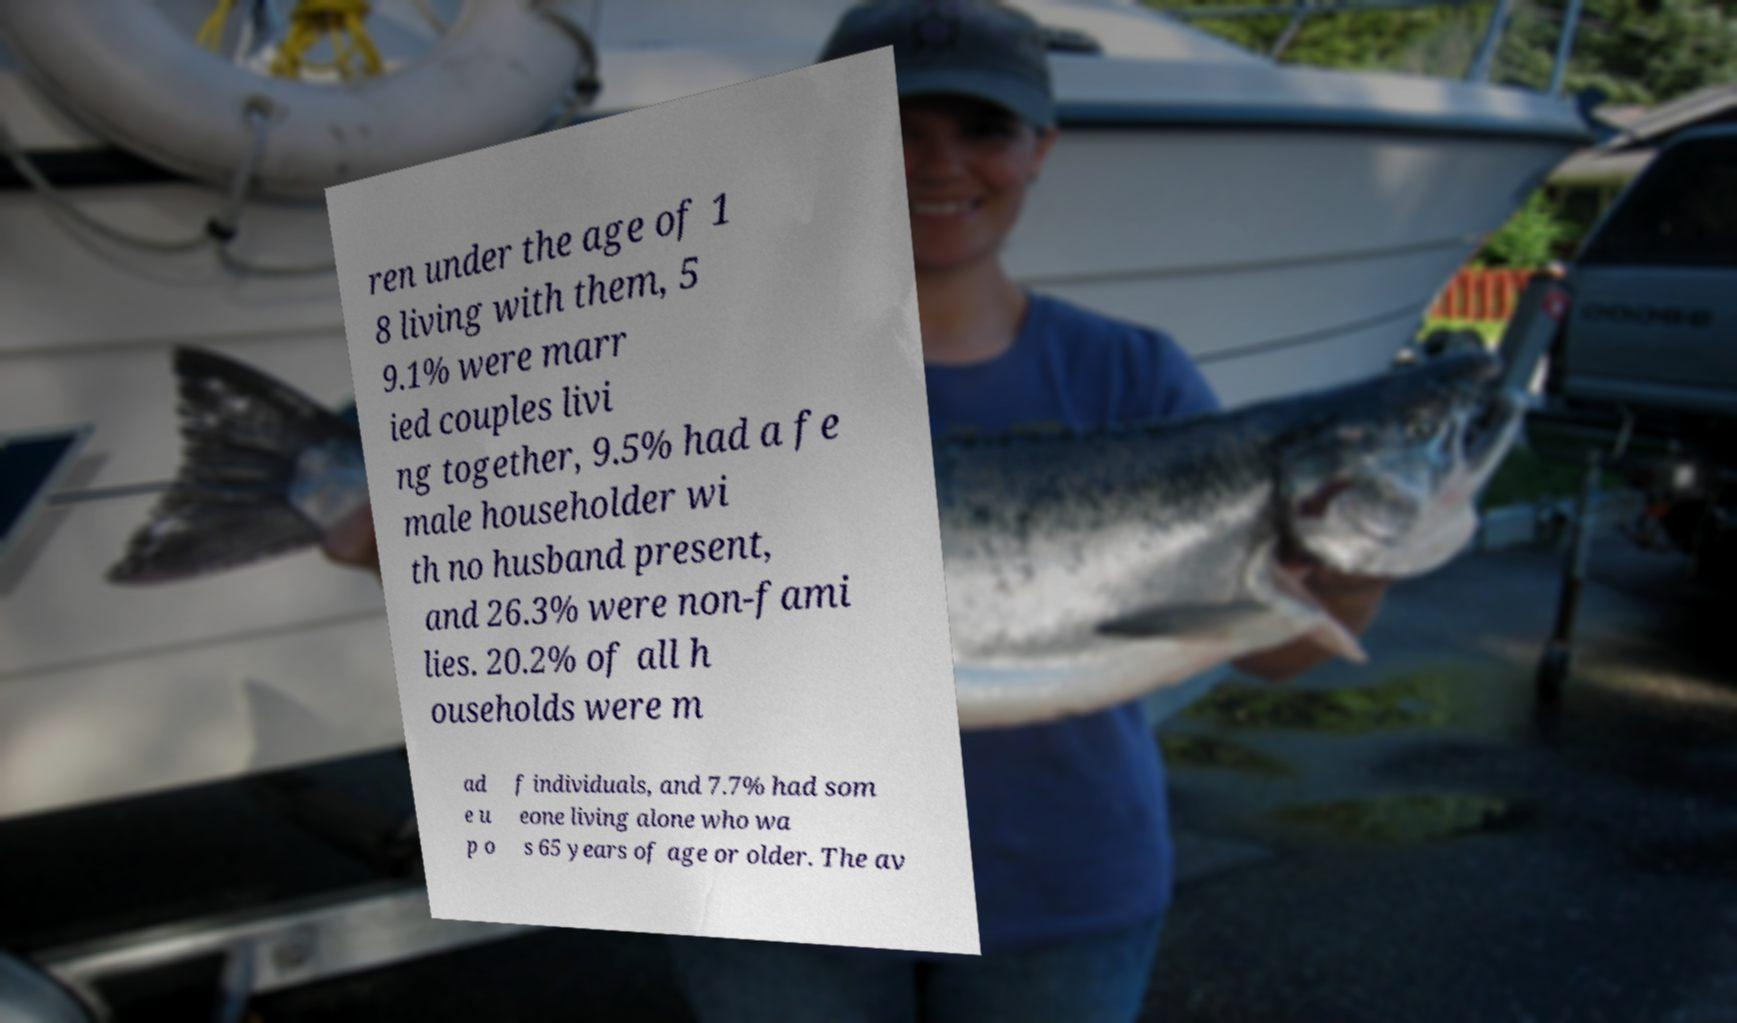There's text embedded in this image that I need extracted. Can you transcribe it verbatim? ren under the age of 1 8 living with them, 5 9.1% were marr ied couples livi ng together, 9.5% had a fe male householder wi th no husband present, and 26.3% were non-fami lies. 20.2% of all h ouseholds were m ad e u p o f individuals, and 7.7% had som eone living alone who wa s 65 years of age or older. The av 